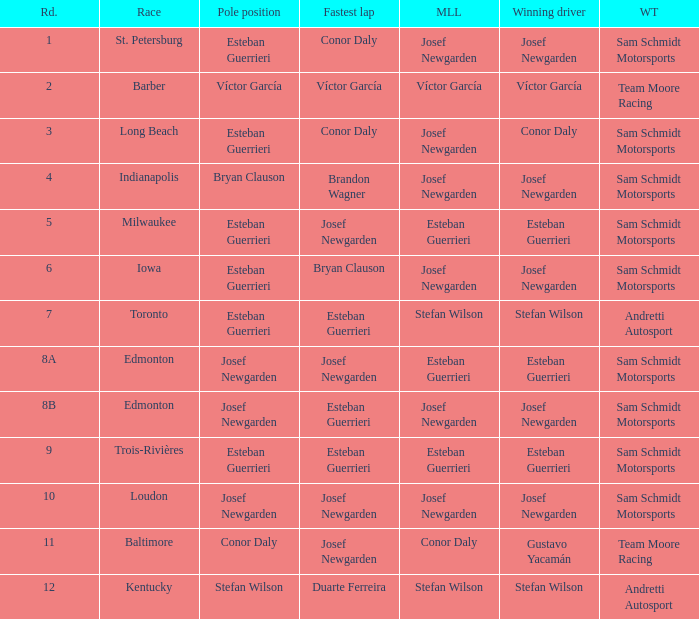Who had the pole(s) when esteban guerrieri led the most laps round 8a and josef newgarden had the fastest lap? Josef Newgarden. 